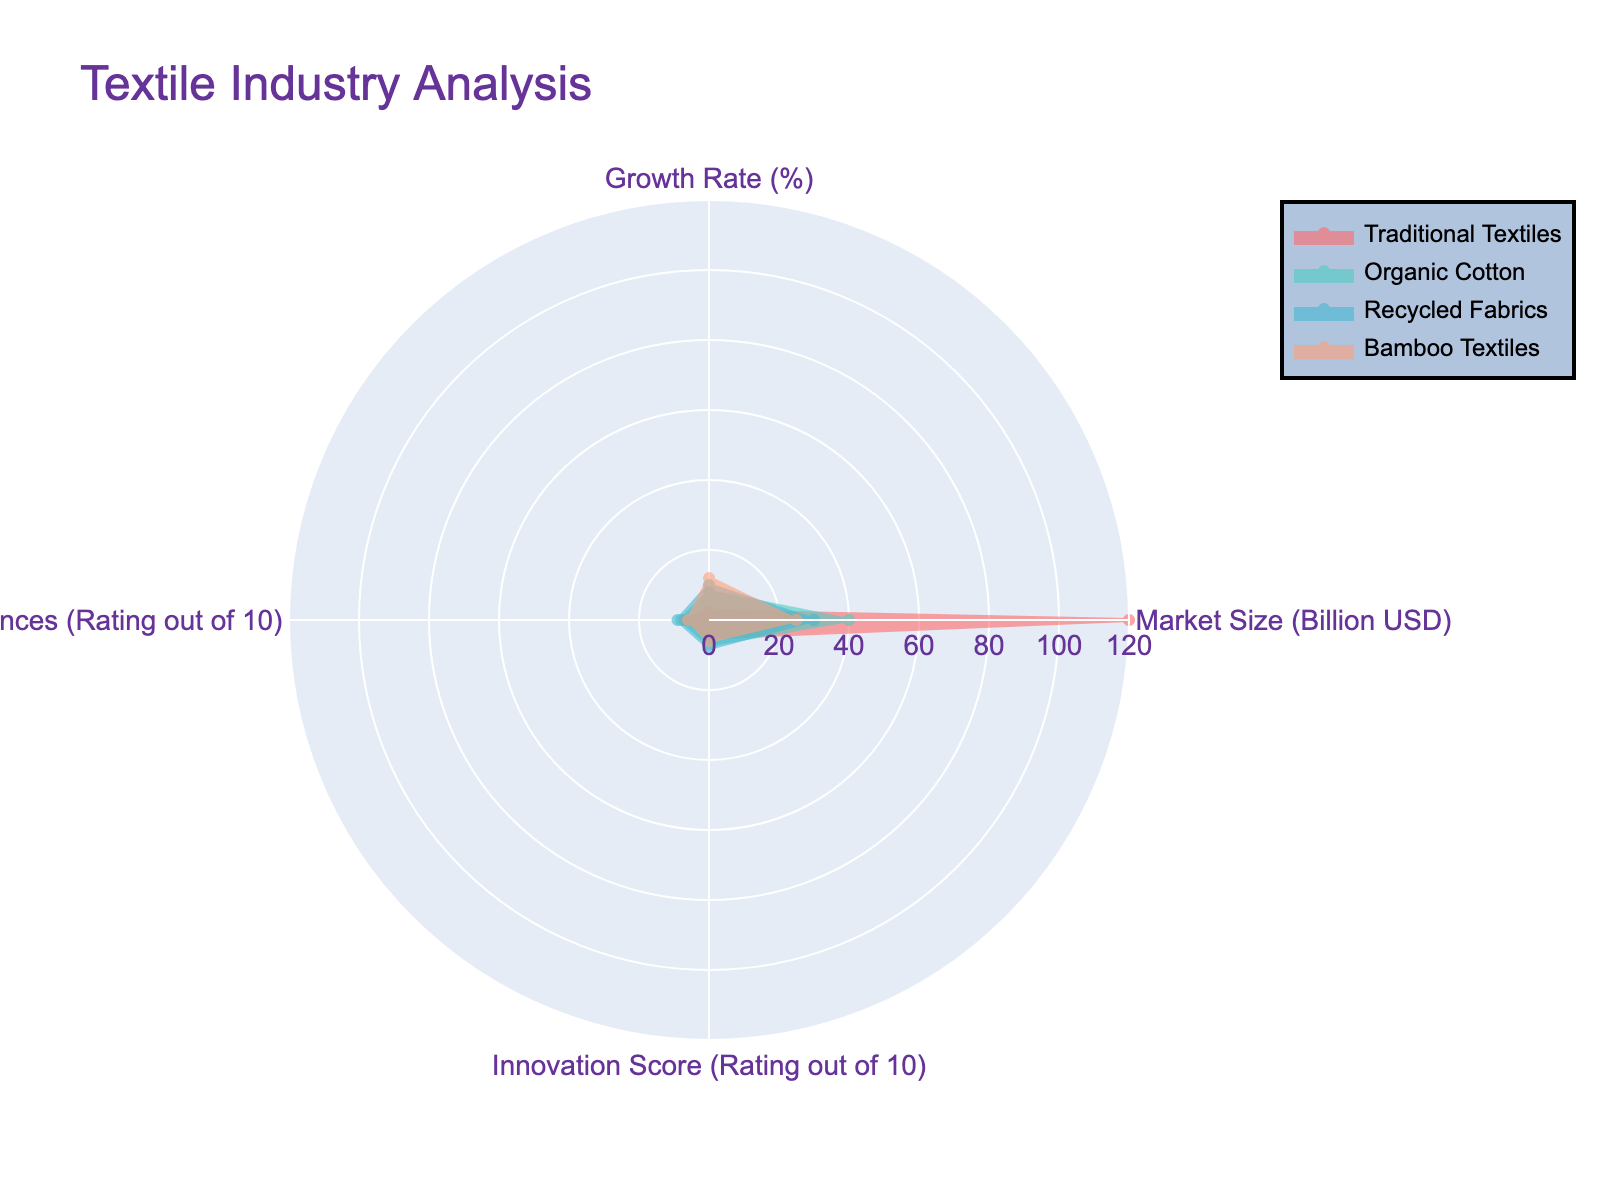What is the title of the radar chart? The title is the text that appears at the top of the radar chart. It provides an overview of what the chart represents. In this case, it is clearly stated at the top of the figure.
Answer: Textile Industry Analysis How many categories are displayed in the radar chart? By counting the different groups or segments represented in the radar chart, we can determine the number of categories. Each segment has a label indicating its category.
Answer: Four Which category has the highest market size? To find this, look at the radial values of "Market Size (Billion USD)" for each category; the highest value will indicate the category with the largest market size.
Answer: Traditional Textiles Which two categories have the highest growth rates, and what are their values? Reviewing the radial values for "Growth Rate (%)" for all categories, we identify the two highest values by comparing these figures.
Answer: Bamboo Textiles (12%), Recycled Fabrics (10%) What is the average consumer preference rating for Organic Cotton and Recycled Fabrics? Look at the "Consumer Preferences (Rating out of 10)" values for both categories, then sum these values and divide by 2 to get the average. Calculation: (8 + 9) / 2 = 8.5
Answer: 8.5 Which category demonstrates an equal level of innovation score as its consumer preferences rating? Examine the "Innovation Score (Rating out of 10)" and "Consumer Preferences (Rating out of 10)" and identify any category where these ratings are equal.
Answer: Bamboo Textiles What is the difference in market size between Traditional Textiles and Bamboo Textiles? Subtract the "Market Size (Billion USD)" of Bamboo Textiles from that of Traditional Textiles. Calculation: 120 - 25 = 95
Answer: 95 Billion USD Which category shows the lowest consumer preference rating, and what is the score? Identify the radial value for "Consumer Preferences (Rating out of 10)" for all categories and find the lowest score.
Answer: Bamboo Textiles (6) How does the innovation score of Recycled Fabrics compare to that of Organic Cotton? Compare their respective "Innovation Score (Rating out of 10)" values by directly looking at the radar chart to see which one is higher.
Answer: Recycled Fabrics (8) is higher than Organic Cotton (7) What is the combined market size of Organic Cotton and Recycled Fabrics? Simply add the "Market Size (Billion USD)" values of Organic Cotton and Recycled Fabrics. Calculation: 40 + 30 = 70
Answer: 70 Billion USD 